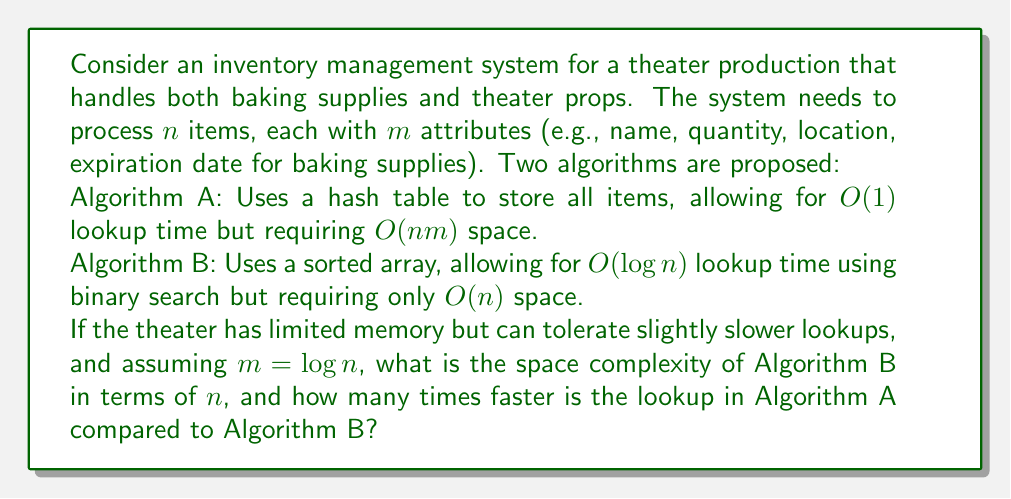Could you help me with this problem? Let's break this down step-by-step:

1. Space complexity:
   - Algorithm A: $O(nm) = O(n \log n)$ (given $m = \log n$)
   - Algorithm B: $O(n)$

2. Time complexity for lookup:
   - Algorithm A: $O(1)$
   - Algorithm B: $O(\log n)$

3. Space comparison:
   Algorithm B uses $O(n)$ space, which is more efficient than Algorithm A's $O(n \log n)$ when memory is limited.

4. Time comparison:
   To find how many times faster Algorithm A is, we need to compare the time complexities:

   $\frac{\text{Time of Algorithm B}}{\text{Time of Algorithm A}} = \frac{O(\log n)}{O(1)} = O(\log n)$

   This means Algorithm A is approximately $\log n$ times faster than Algorithm B.

5. Interpreting the result:
   For a theater inventory system, $n$ might be in the thousands. For example, if $n = 1000$:
   
   $\log 1000 \approx 10$

   So Algorithm A would be about 10 times faster for lookups, but at the cost of using more memory.
Answer: The space complexity of Algorithm B is $O(n)$, and Algorithm A's lookup is $O(\log n)$ times faster than Algorithm B's lookup. 